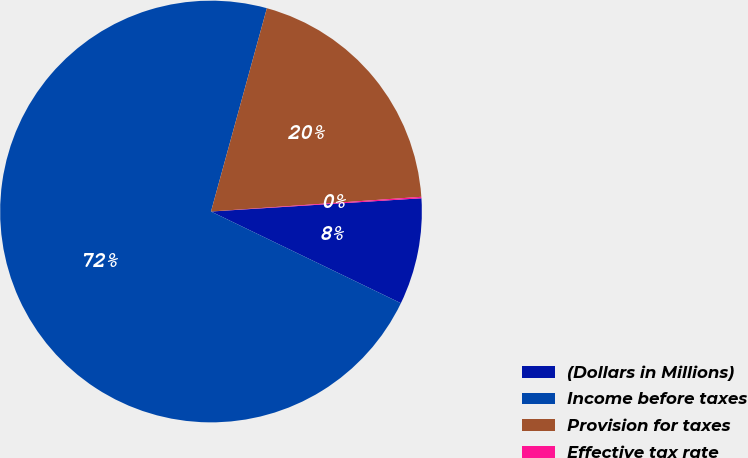Convert chart. <chart><loc_0><loc_0><loc_500><loc_500><pie_chart><fcel>(Dollars in Millions)<fcel>Income before taxes<fcel>Provision for taxes<fcel>Effective tax rate<nl><fcel>8.16%<fcel>72.11%<fcel>19.62%<fcel>0.11%<nl></chart> 